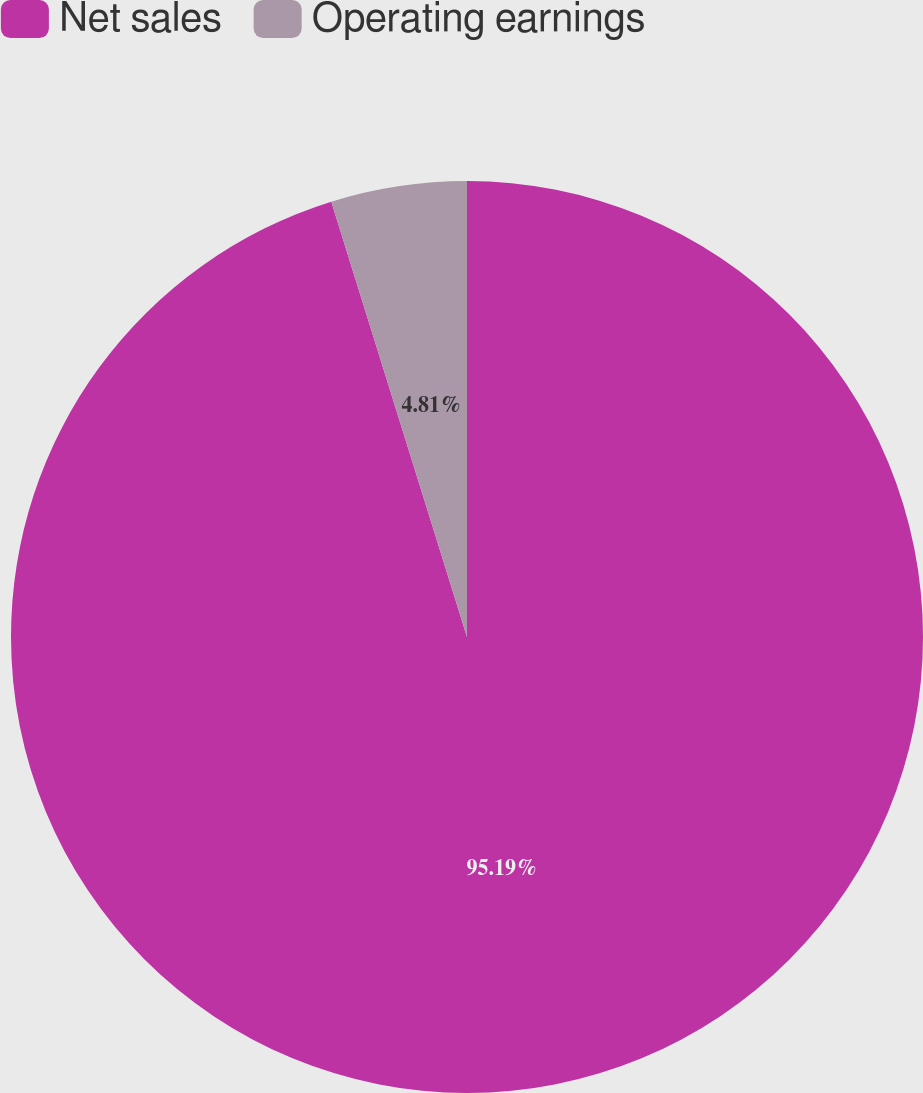<chart> <loc_0><loc_0><loc_500><loc_500><pie_chart><fcel>Net sales<fcel>Operating earnings<nl><fcel>95.19%<fcel>4.81%<nl></chart> 